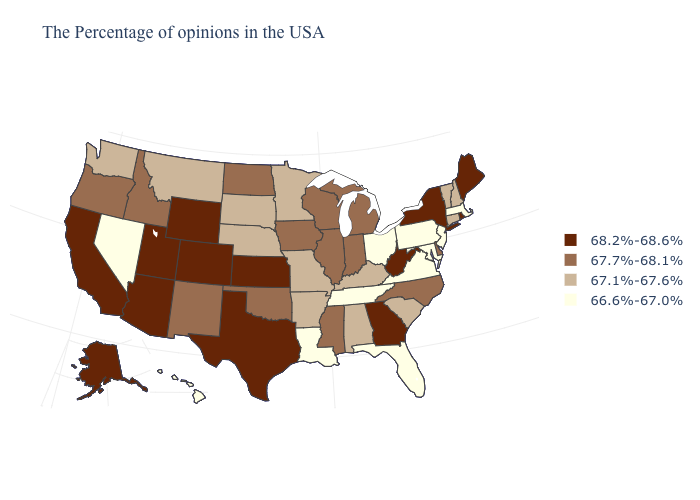Among the states that border Montana , does South Dakota have the lowest value?
Short answer required. Yes. Is the legend a continuous bar?
Write a very short answer. No. What is the lowest value in the South?
Short answer required. 66.6%-67.0%. Among the states that border Alabama , which have the highest value?
Short answer required. Georgia. What is the value of Indiana?
Concise answer only. 67.7%-68.1%. Which states have the highest value in the USA?
Keep it brief. Maine, Rhode Island, New York, West Virginia, Georgia, Kansas, Texas, Wyoming, Colorado, Utah, Arizona, California, Alaska. What is the value of Maine?
Answer briefly. 68.2%-68.6%. Name the states that have a value in the range 67.1%-67.6%?
Give a very brief answer. New Hampshire, Vermont, Connecticut, South Carolina, Kentucky, Alabama, Missouri, Arkansas, Minnesota, Nebraska, South Dakota, Montana, Washington. What is the value of Iowa?
Write a very short answer. 67.7%-68.1%. Is the legend a continuous bar?
Quick response, please. No. What is the highest value in the South ?
Answer briefly. 68.2%-68.6%. Is the legend a continuous bar?
Be succinct. No. What is the value of Florida?
Short answer required. 66.6%-67.0%. Does the first symbol in the legend represent the smallest category?
Quick response, please. No. What is the lowest value in states that border Mississippi?
Quick response, please. 66.6%-67.0%. 